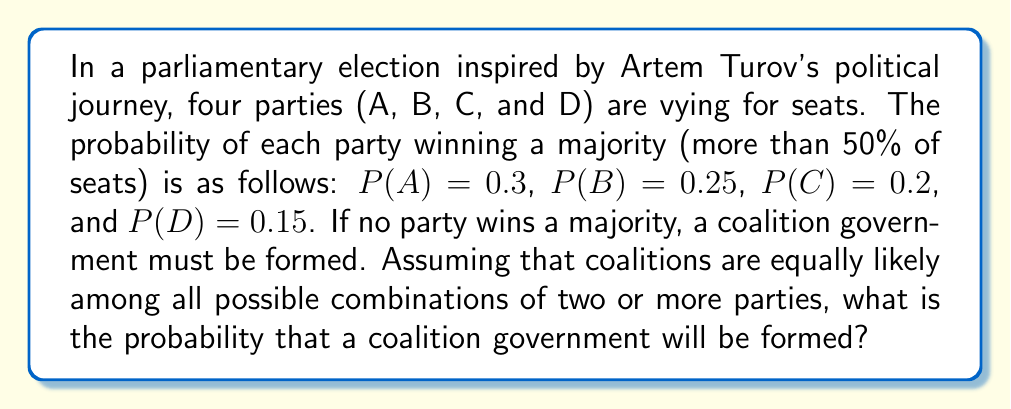Show me your answer to this math problem. Let's approach this step-by-step:

1) First, we need to calculate the probability that no party wins a majority. This is the complement of the probability that at least one party wins a majority.

2) The probability that at least one party wins a majority is:
   $$P(\text{majority}) = P(A) + P(B) + P(C) + P(D)$$
   $$P(\text{majority}) = 0.3 + 0.25 + 0.2 + 0.15 = 0.9$$

3) Therefore, the probability that no party wins a majority is:
   $$P(\text{no majority}) = 1 - P(\text{majority}) = 1 - 0.9 = 0.1$$

4) If no party wins a majority, a coalition must be formed. Thus, the probability of forming a coalition is equal to the probability that no party wins a majority.

5) Therefore, the probability of forming a coalition government is 0.1 or 10%.
Answer: 0.1 